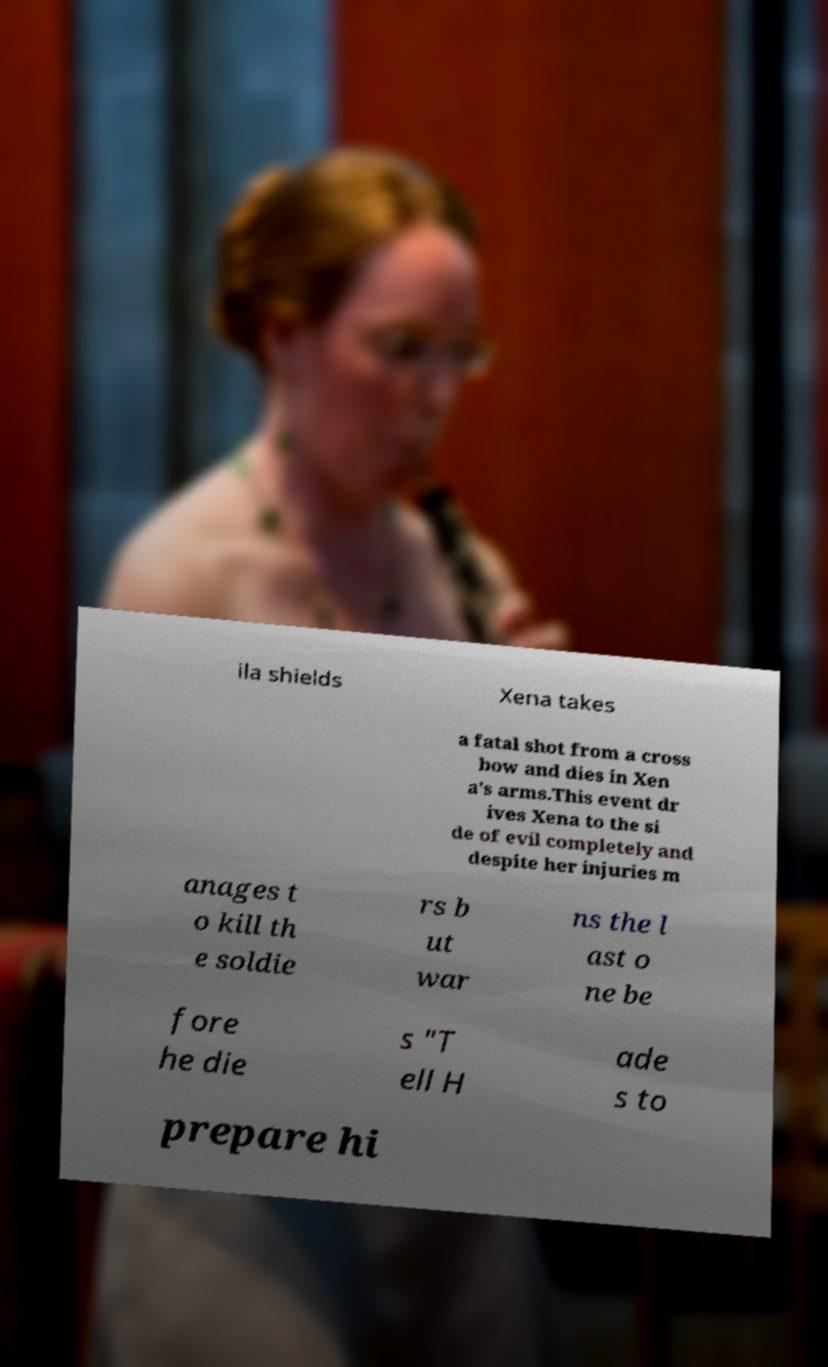Can you accurately transcribe the text from the provided image for me? ila shields Xena takes a fatal shot from a cross bow and dies in Xen a's arms.This event dr ives Xena to the si de of evil completely and despite her injuries m anages t o kill th e soldie rs b ut war ns the l ast o ne be fore he die s "T ell H ade s to prepare hi 